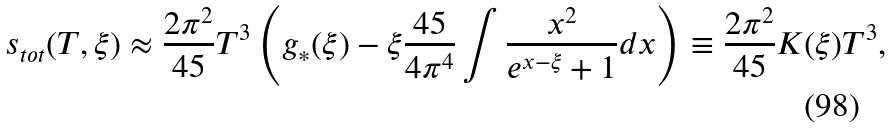Convert formula to latex. <formula><loc_0><loc_0><loc_500><loc_500>s _ { t o t } ( T , \xi ) \approx \frac { 2 \pi ^ { 2 } } { 4 5 } T ^ { 3 } \left ( g _ { \ast } ( \xi ) - \xi \frac { 4 5 } { 4 \pi ^ { 4 } } \int \frac { x ^ { 2 } } { e ^ { x - \xi } + 1 } d x \right ) \equiv \frac { 2 \pi ^ { 2 } } { 4 5 } K ( \xi ) T ^ { 3 } ,</formula> 